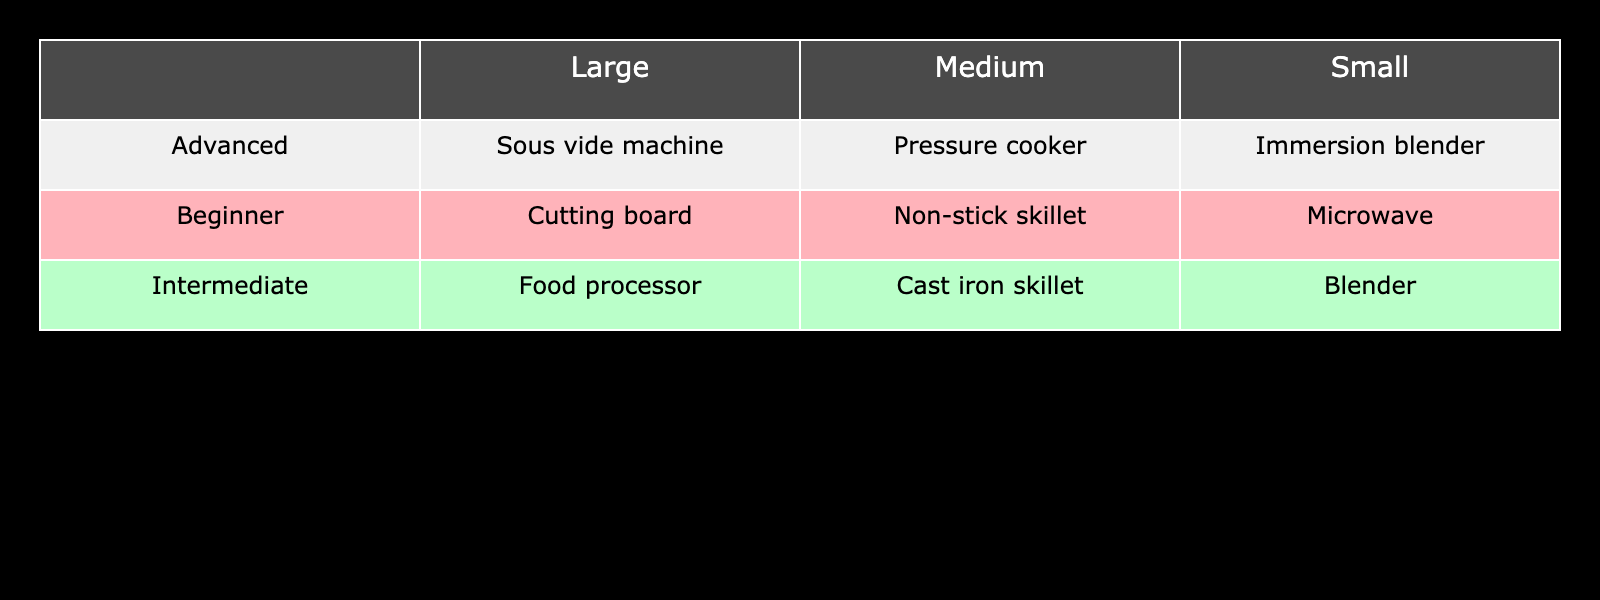What popular cooking tool is used by beginners in a small kitchen? According to the table, the popular cooking tool for beginners in a small kitchen is the microwave. This is directly taken from the row for "Beginner" in the "Small" kitchen size column.
Answer: Microwave Which cooking tool do advanced cooks prefer in a medium-sized kitchen? The table shows that advanced cooks use a pressure cooker in a medium-sized kitchen. This can be found in the "Advanced" row under the "Medium" kitchen size column.
Answer: Pressure cooker How many different cooking tools are listed for intermediate cooks across all kitchen sizes? The table has three entries for intermediate cooks: blender for small, cast iron skillet for medium, and food processor for large. Adding these gives a total of 3 different tools.
Answer: 3 Is the food processor the only popular cooking tool associated with large kitchens? Checking the table, the food processor is listed for intermediate cooks in a large kitchen, but there are also other tools listed for advanced cooks in large kitchens, such as the sous vide machine. Therefore, the statement is false.
Answer: No Which cooking skill level has a cutting board listed as their popular cooking tool? The table indicates that the cutting board is associated with beginners in a large kitchen. This data point can be verified under the "Large" column for "Beginner."
Answer: Beginner What is the difference between the number of tools used by beginner cooks in small and large kitchens? In the small kitchen, beginners have one tool (microwave), and in the large kitchen, they also have one tool (cutting board). The difference between the number of tools is 1 - 1 = 0.
Answer: 0 Which kitchen size has the most variety of popular cooking tools? By reviewing the table, small kitchens have 3 tools (microwave, blender, immersion blender), medium kitchens also have 3 tools (non-stick skillet, cast iron skillet, pressure cooker), and large kitchens have 3 tools (cutting board, food processor, sous vide machine). Hence, all sizes have an equal variety of tools, resulting in no clear answer.
Answer: Equal variety across all sizes Are intermediate cooks more likely to use a blender than advanced cooks? The table shows that intermediate cooks use a blender in a small kitchen, while advanced cooks use an immersion blender in the same size kitchen. Since each of them has one distinct tool without repetition, the answer is false.
Answer: No Which cooking tool is unique to advanced cooks and not found within the other skill levels? The sous vide machine is specifically listed for advanced cooks in large kitchens, making it a unique cooking tool not found in the other skill levels. Thus, this statement can be confirmed as true.
Answer: Yes 